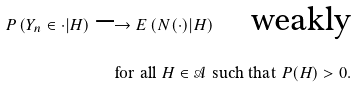<formula> <loc_0><loc_0><loc_500><loc_500>P \left ( Y _ { n } \in \cdot | H \right ) \longrightarrow E \left ( N ( \cdot ) | H \right ) \quad \text {weakly} \\ \text {for all } H \in \mathcal { A } \text { such that } P ( H ) > 0 .</formula> 